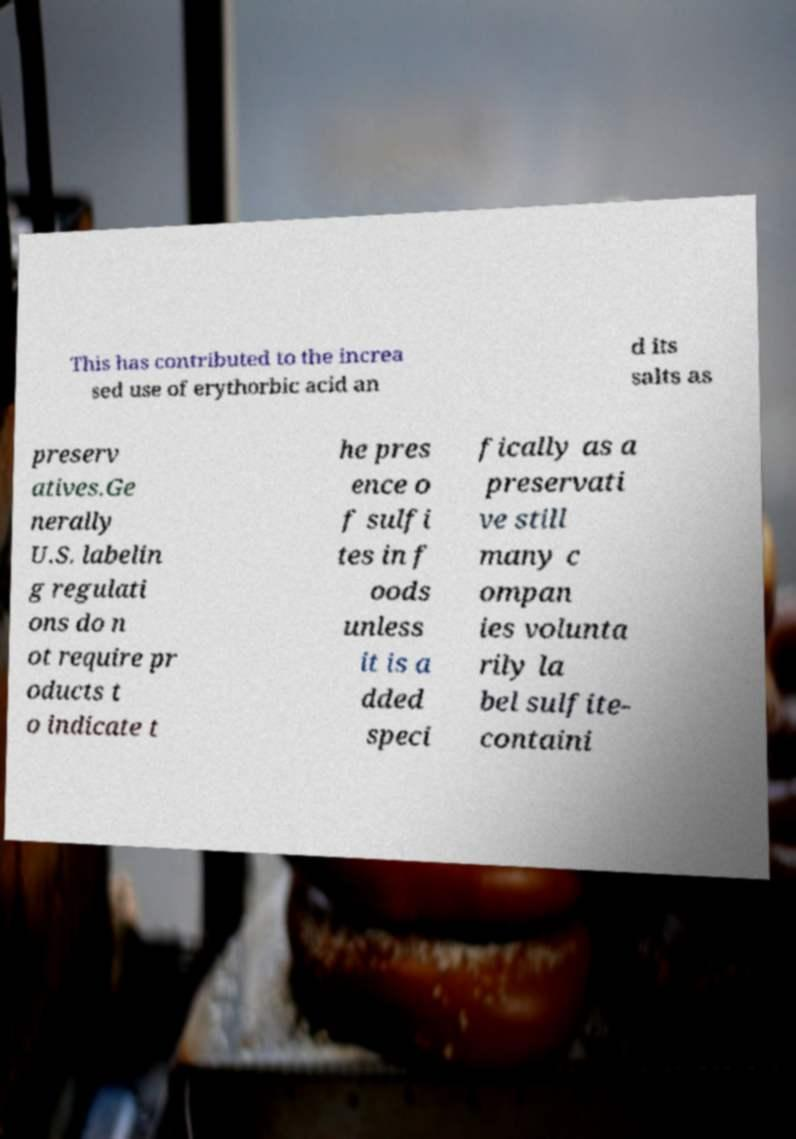What messages or text are displayed in this image? I need them in a readable, typed format. This has contributed to the increa sed use of erythorbic acid an d its salts as preserv atives.Ge nerally U.S. labelin g regulati ons do n ot require pr oducts t o indicate t he pres ence o f sulfi tes in f oods unless it is a dded speci fically as a preservati ve still many c ompan ies volunta rily la bel sulfite- containi 